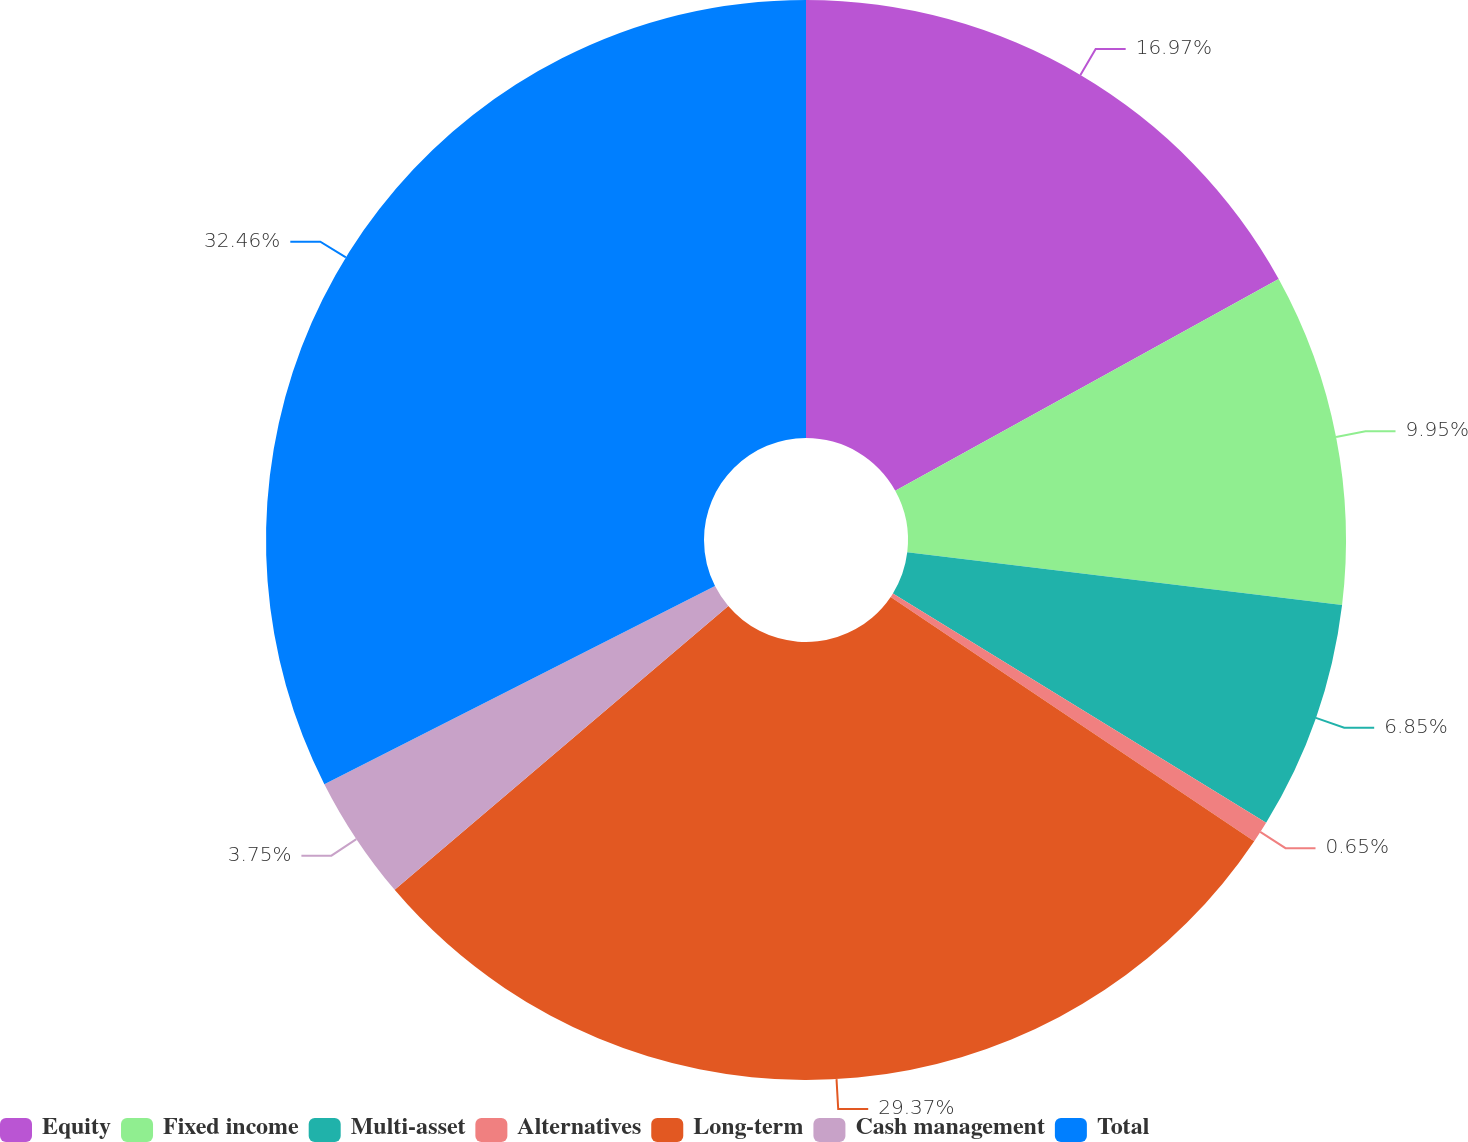Convert chart to OTSL. <chart><loc_0><loc_0><loc_500><loc_500><pie_chart><fcel>Equity<fcel>Fixed income<fcel>Multi-asset<fcel>Alternatives<fcel>Long-term<fcel>Cash management<fcel>Total<nl><fcel>16.97%<fcel>9.95%<fcel>6.85%<fcel>0.65%<fcel>29.37%<fcel>3.75%<fcel>32.47%<nl></chart> 